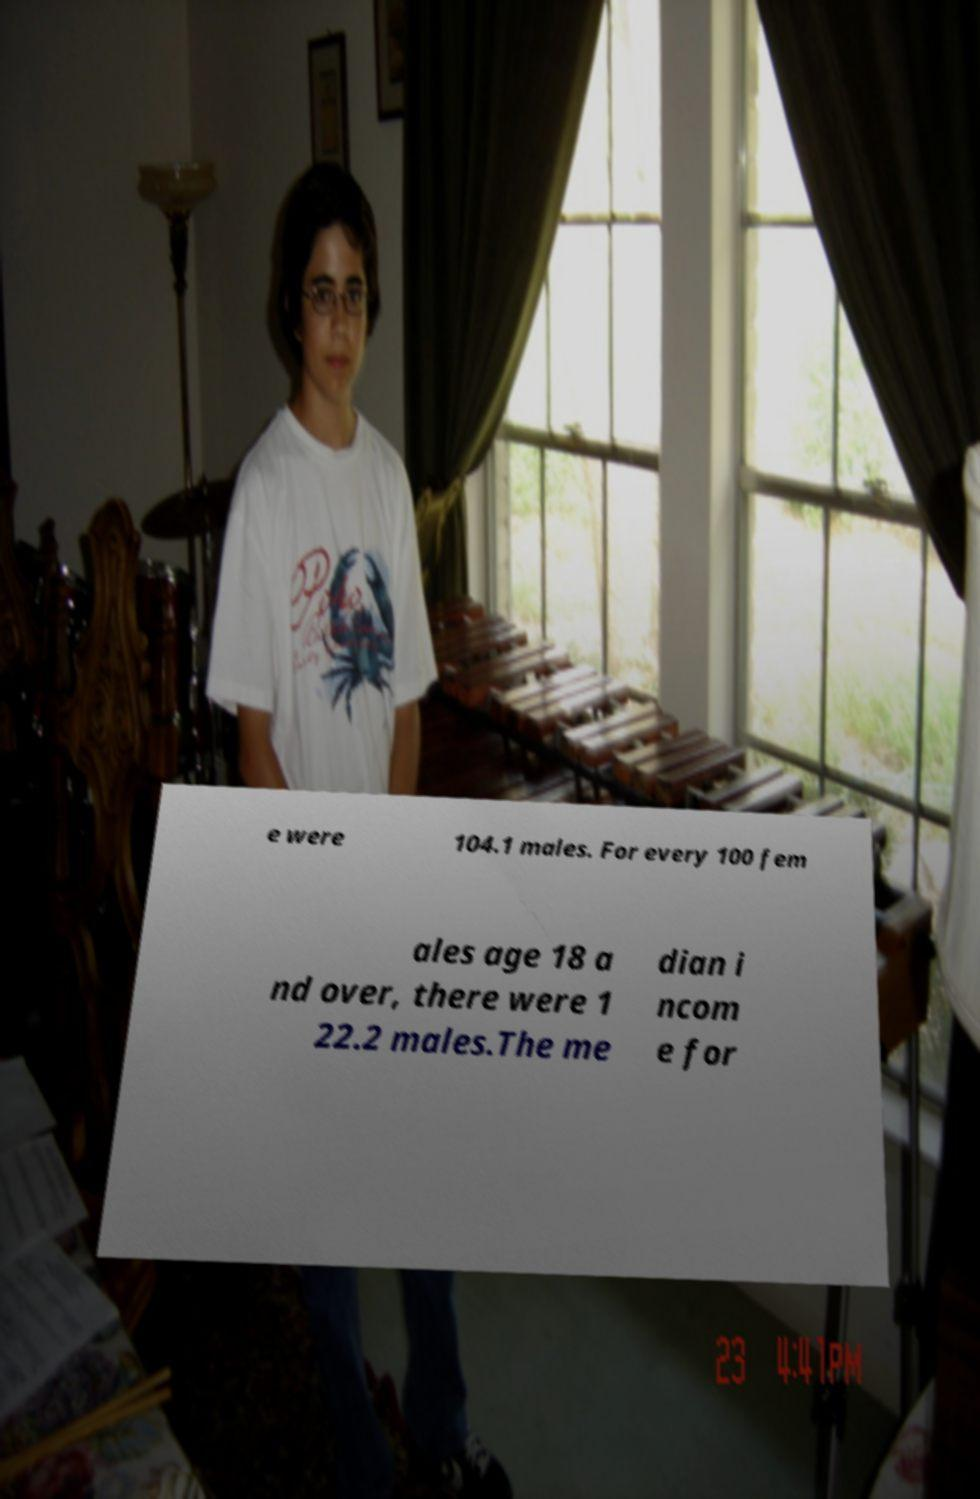Could you assist in decoding the text presented in this image and type it out clearly? e were 104.1 males. For every 100 fem ales age 18 a nd over, there were 1 22.2 males.The me dian i ncom e for 